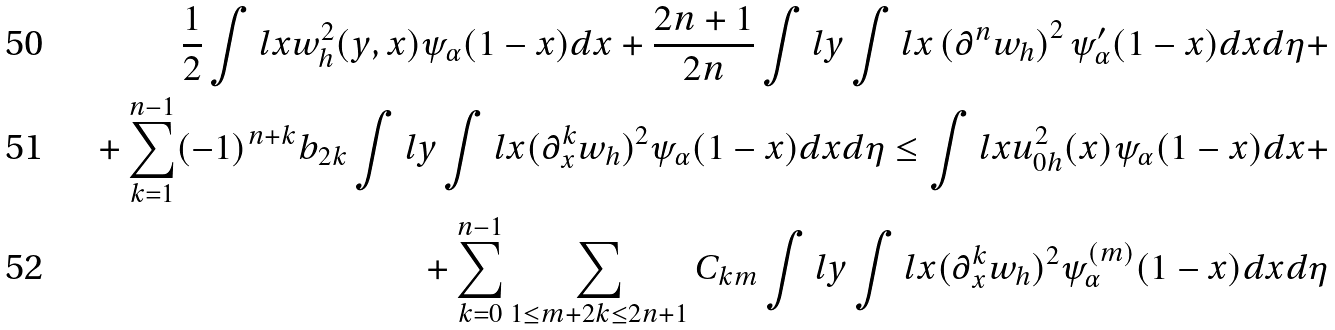Convert formula to latex. <formula><loc_0><loc_0><loc_500><loc_500>\frac { 1 } { 2 } \int l x w _ { h } ^ { 2 } ( y , x ) \psi _ { \alpha } ( 1 - x ) d x + \frac { 2 n + 1 } { 2 n } \int l y \int l x \left ( \partial ^ { n } w _ { h } \right ) ^ { 2 } \psi _ { \alpha } ^ { \prime } ( 1 - x ) d x d \eta + \\ + \sum _ { k = 1 } ^ { n - 1 } ( - 1 ) ^ { n + k } b _ { 2 k } \int l y \int l x ( \partial _ { x } ^ { k } w _ { h } ) ^ { 2 } \psi _ { \alpha } ( 1 - x ) d x d \eta \leq \int l x u _ { 0 h } ^ { 2 } ( x ) \psi _ { \alpha } ( 1 - x ) d x + \\ + \sum _ { k = 0 } ^ { n - 1 } \sum _ { 1 \leq m + 2 k \leq 2 n + 1 } C _ { k m } \int l y \int l x ( \partial _ { x } ^ { k } w _ { h } ) ^ { 2 } \psi _ { \alpha } ^ { ( m ) } ( 1 - x ) d x d \eta</formula> 